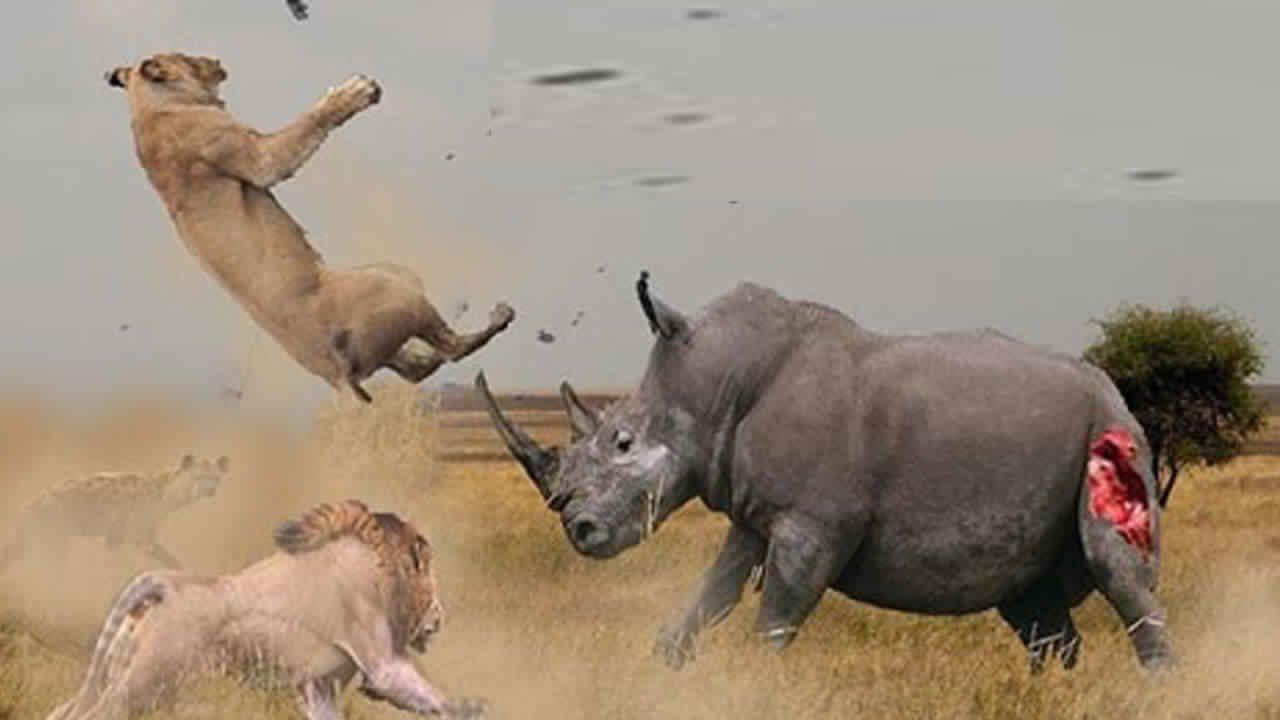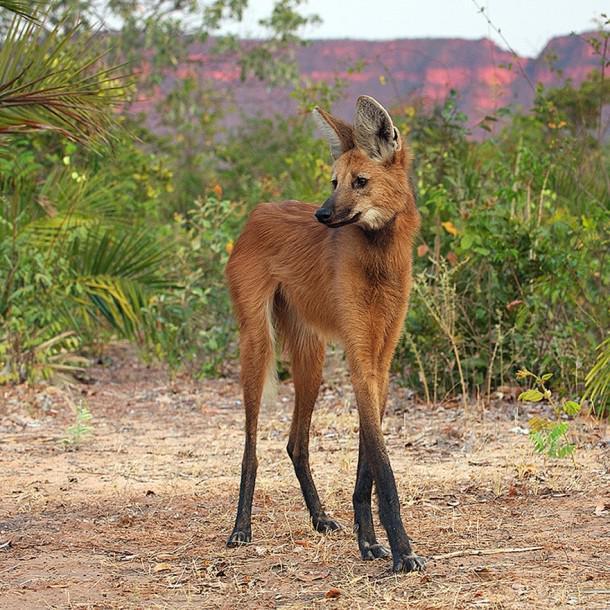The first image is the image on the left, the second image is the image on the right. Assess this claim about the two images: "The hyena in the right image is baring its teeth.". Correct or not? Answer yes or no. No. 